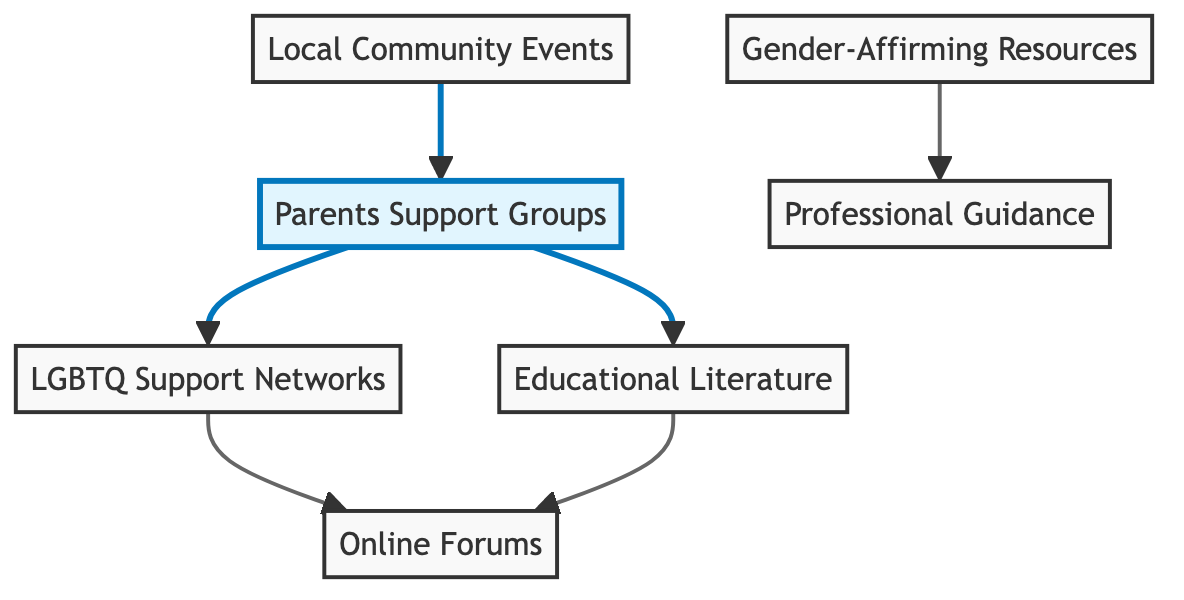What are the nodes in this diagram? The diagram contains the following nodes: Parents Support Groups, LGBTQ Support Networks, Gender-Affirming Resources, Educational Literature, Online Forums, Professional Guidance, and Local Community Events.
Answer: Parents Support Groups, LGBTQ Support Networks, Gender-Affirming Resources, Educational Literature, Online Forums, Professional Guidance, Local Community Events How many edges are there in total? To find the total number of edges, we count them: Parents Support Groups to LGBTQ Support Networks, Parents Support Groups to Educational Literature, LGBTQ Support Networks to Online Forums, Gender-Affirming Resources to Professional Guidance, Educational Literature to Online Forums, and Local Community Events to Parents Support Groups. This gives us a total of 6 edges.
Answer: 6 Which node is highlighted in the diagram? The highlighted node in the diagram is Parents Support Groups, indicating its primary importance among the resources presented.
Answer: Parents Support Groups What is the relationship between Parents Support Groups and Online Forums? There is no direct connection from Parents Support Groups to Online Forums, but there is an indirect connection through LGBTQ Support Networks and Educational Literature, showing that Parents Support Groups can lead to Online Forums via other resources.
Answer: No direct connection Which resources provide Professional Guidance? The resource connected to Professional Guidance is Gender-Affirming Resources, indicating it as a source of professional assistance and advice.
Answer: Gender-Affirming Resources What is the relationship between LGBTQ Support Networks and Online Forums? LGBTQ Support Networks has a direct connection to Online Forums, indicating that these networks provide access to online discussions and community support.
Answer: Direct connection How many nodes are connected to Parents Support Groups? Parents Support Groups connects to two nodes directly: LGBTQ Support Networks and Educational Literature, and has Local Community Events linking back to it, but only the first two are directly connected.
Answer: 2 Which nodes are indirectly connected to Educational Literature? Educational Literature connects directly to Online Forums and also has an indirect connection to Parents Support Groups through the edges leading from it to Local Community Events, creating a circular flow of support that relates back to the Parents Support Groups.
Answer: Online Forums, Parents Support Groups What role do Local Community Events play in the diagram? Local Community Events connects back to Parents Support Groups, suggesting that these events contribute to building or enhancing support networks for parents, making them an essential resource.
Answer: Connects to Parents Support Groups 